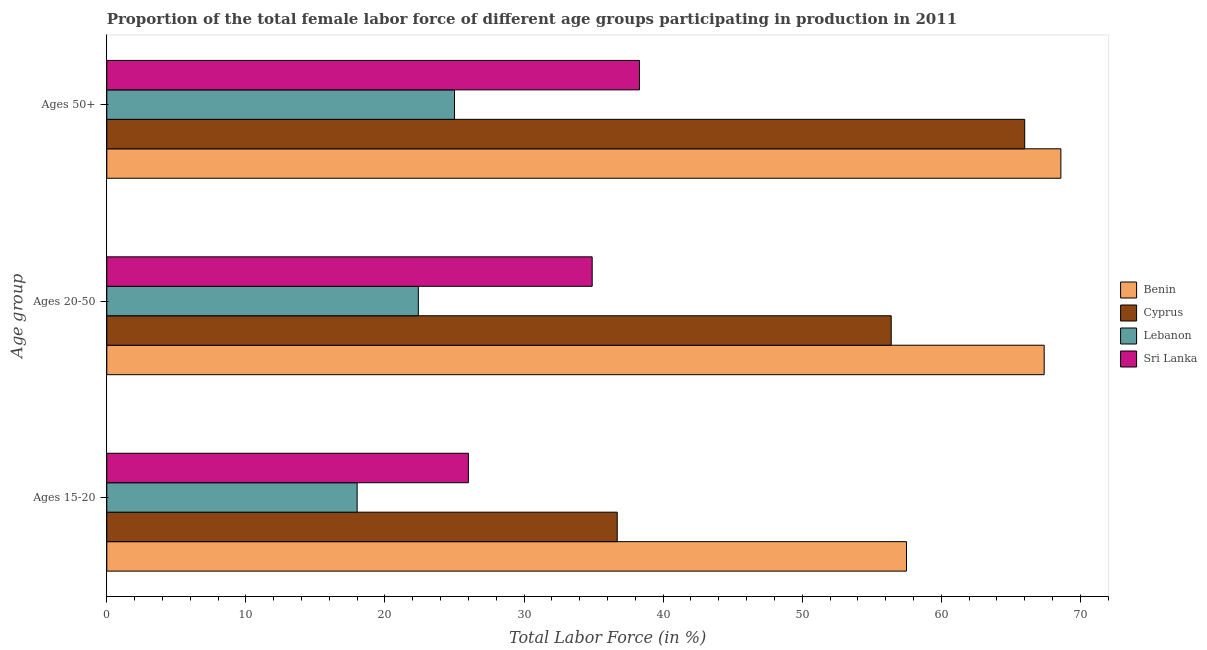Are the number of bars on each tick of the Y-axis equal?
Ensure brevity in your answer.  Yes. How many bars are there on the 1st tick from the bottom?
Your answer should be very brief. 4. What is the label of the 1st group of bars from the top?
Your answer should be compact. Ages 50+. What is the percentage of female labor force within the age group 20-50 in Sri Lanka?
Ensure brevity in your answer.  34.9. Across all countries, what is the maximum percentage of female labor force above age 50?
Your answer should be very brief. 68.6. Across all countries, what is the minimum percentage of female labor force within the age group 20-50?
Provide a succinct answer. 22.4. In which country was the percentage of female labor force within the age group 20-50 maximum?
Offer a terse response. Benin. In which country was the percentage of female labor force above age 50 minimum?
Offer a terse response. Lebanon. What is the total percentage of female labor force within the age group 15-20 in the graph?
Your answer should be very brief. 138.2. What is the difference between the percentage of female labor force above age 50 in Benin and that in Cyprus?
Ensure brevity in your answer.  2.6. What is the difference between the percentage of female labor force within the age group 20-50 in Cyprus and the percentage of female labor force within the age group 15-20 in Benin?
Provide a succinct answer. -1.1. What is the average percentage of female labor force within the age group 20-50 per country?
Offer a terse response. 45.28. What is the difference between the percentage of female labor force within the age group 20-50 and percentage of female labor force above age 50 in Sri Lanka?
Make the answer very short. -3.4. In how many countries, is the percentage of female labor force within the age group 15-20 greater than 42 %?
Ensure brevity in your answer.  1. What is the ratio of the percentage of female labor force above age 50 in Cyprus to that in Sri Lanka?
Give a very brief answer. 1.72. Is the difference between the percentage of female labor force above age 50 in Lebanon and Cyprus greater than the difference between the percentage of female labor force within the age group 15-20 in Lebanon and Cyprus?
Provide a succinct answer. No. What is the difference between the highest and the second highest percentage of female labor force above age 50?
Offer a very short reply. 2.6. What is the difference between the highest and the lowest percentage of female labor force within the age group 20-50?
Your answer should be very brief. 45. In how many countries, is the percentage of female labor force within the age group 15-20 greater than the average percentage of female labor force within the age group 15-20 taken over all countries?
Provide a short and direct response. 2. What does the 3rd bar from the top in Ages 20-50 represents?
Provide a short and direct response. Cyprus. What does the 4th bar from the bottom in Ages 15-20 represents?
Offer a terse response. Sri Lanka. Is it the case that in every country, the sum of the percentage of female labor force within the age group 15-20 and percentage of female labor force within the age group 20-50 is greater than the percentage of female labor force above age 50?
Keep it short and to the point. Yes. What is the difference between two consecutive major ticks on the X-axis?
Provide a succinct answer. 10. Does the graph contain any zero values?
Give a very brief answer. No. What is the title of the graph?
Your response must be concise. Proportion of the total female labor force of different age groups participating in production in 2011. Does "Guyana" appear as one of the legend labels in the graph?
Provide a short and direct response. No. What is the label or title of the X-axis?
Make the answer very short. Total Labor Force (in %). What is the label or title of the Y-axis?
Ensure brevity in your answer.  Age group. What is the Total Labor Force (in %) in Benin in Ages 15-20?
Your answer should be very brief. 57.5. What is the Total Labor Force (in %) in Cyprus in Ages 15-20?
Keep it short and to the point. 36.7. What is the Total Labor Force (in %) in Sri Lanka in Ages 15-20?
Ensure brevity in your answer.  26. What is the Total Labor Force (in %) in Benin in Ages 20-50?
Make the answer very short. 67.4. What is the Total Labor Force (in %) in Cyprus in Ages 20-50?
Offer a terse response. 56.4. What is the Total Labor Force (in %) of Lebanon in Ages 20-50?
Your answer should be very brief. 22.4. What is the Total Labor Force (in %) in Sri Lanka in Ages 20-50?
Offer a very short reply. 34.9. What is the Total Labor Force (in %) of Benin in Ages 50+?
Give a very brief answer. 68.6. What is the Total Labor Force (in %) of Cyprus in Ages 50+?
Give a very brief answer. 66. What is the Total Labor Force (in %) in Sri Lanka in Ages 50+?
Ensure brevity in your answer.  38.3. Across all Age group, what is the maximum Total Labor Force (in %) in Benin?
Ensure brevity in your answer.  68.6. Across all Age group, what is the maximum Total Labor Force (in %) of Cyprus?
Your answer should be compact. 66. Across all Age group, what is the maximum Total Labor Force (in %) of Sri Lanka?
Your answer should be very brief. 38.3. Across all Age group, what is the minimum Total Labor Force (in %) of Benin?
Make the answer very short. 57.5. Across all Age group, what is the minimum Total Labor Force (in %) of Cyprus?
Your response must be concise. 36.7. Across all Age group, what is the minimum Total Labor Force (in %) in Lebanon?
Give a very brief answer. 18. Across all Age group, what is the minimum Total Labor Force (in %) of Sri Lanka?
Your response must be concise. 26. What is the total Total Labor Force (in %) of Benin in the graph?
Your response must be concise. 193.5. What is the total Total Labor Force (in %) of Cyprus in the graph?
Ensure brevity in your answer.  159.1. What is the total Total Labor Force (in %) in Lebanon in the graph?
Provide a short and direct response. 65.4. What is the total Total Labor Force (in %) of Sri Lanka in the graph?
Ensure brevity in your answer.  99.2. What is the difference between the Total Labor Force (in %) of Cyprus in Ages 15-20 and that in Ages 20-50?
Keep it short and to the point. -19.7. What is the difference between the Total Labor Force (in %) of Cyprus in Ages 15-20 and that in Ages 50+?
Ensure brevity in your answer.  -29.3. What is the difference between the Total Labor Force (in %) of Lebanon in Ages 15-20 and that in Ages 50+?
Offer a very short reply. -7. What is the difference between the Total Labor Force (in %) of Sri Lanka in Ages 15-20 and that in Ages 50+?
Keep it short and to the point. -12.3. What is the difference between the Total Labor Force (in %) in Benin in Ages 20-50 and that in Ages 50+?
Your response must be concise. -1.2. What is the difference between the Total Labor Force (in %) of Cyprus in Ages 20-50 and that in Ages 50+?
Your answer should be compact. -9.6. What is the difference between the Total Labor Force (in %) in Lebanon in Ages 20-50 and that in Ages 50+?
Offer a very short reply. -2.6. What is the difference between the Total Labor Force (in %) of Benin in Ages 15-20 and the Total Labor Force (in %) of Cyprus in Ages 20-50?
Ensure brevity in your answer.  1.1. What is the difference between the Total Labor Force (in %) of Benin in Ages 15-20 and the Total Labor Force (in %) of Lebanon in Ages 20-50?
Offer a terse response. 35.1. What is the difference between the Total Labor Force (in %) in Benin in Ages 15-20 and the Total Labor Force (in %) in Sri Lanka in Ages 20-50?
Offer a terse response. 22.6. What is the difference between the Total Labor Force (in %) in Cyprus in Ages 15-20 and the Total Labor Force (in %) in Lebanon in Ages 20-50?
Provide a succinct answer. 14.3. What is the difference between the Total Labor Force (in %) of Lebanon in Ages 15-20 and the Total Labor Force (in %) of Sri Lanka in Ages 20-50?
Offer a very short reply. -16.9. What is the difference between the Total Labor Force (in %) of Benin in Ages 15-20 and the Total Labor Force (in %) of Cyprus in Ages 50+?
Your response must be concise. -8.5. What is the difference between the Total Labor Force (in %) of Benin in Ages 15-20 and the Total Labor Force (in %) of Lebanon in Ages 50+?
Provide a succinct answer. 32.5. What is the difference between the Total Labor Force (in %) of Cyprus in Ages 15-20 and the Total Labor Force (in %) of Lebanon in Ages 50+?
Your answer should be very brief. 11.7. What is the difference between the Total Labor Force (in %) of Cyprus in Ages 15-20 and the Total Labor Force (in %) of Sri Lanka in Ages 50+?
Provide a succinct answer. -1.6. What is the difference between the Total Labor Force (in %) of Lebanon in Ages 15-20 and the Total Labor Force (in %) of Sri Lanka in Ages 50+?
Offer a terse response. -20.3. What is the difference between the Total Labor Force (in %) in Benin in Ages 20-50 and the Total Labor Force (in %) in Cyprus in Ages 50+?
Give a very brief answer. 1.4. What is the difference between the Total Labor Force (in %) in Benin in Ages 20-50 and the Total Labor Force (in %) in Lebanon in Ages 50+?
Ensure brevity in your answer.  42.4. What is the difference between the Total Labor Force (in %) of Benin in Ages 20-50 and the Total Labor Force (in %) of Sri Lanka in Ages 50+?
Your answer should be compact. 29.1. What is the difference between the Total Labor Force (in %) of Cyprus in Ages 20-50 and the Total Labor Force (in %) of Lebanon in Ages 50+?
Your answer should be very brief. 31.4. What is the difference between the Total Labor Force (in %) of Lebanon in Ages 20-50 and the Total Labor Force (in %) of Sri Lanka in Ages 50+?
Make the answer very short. -15.9. What is the average Total Labor Force (in %) of Benin per Age group?
Give a very brief answer. 64.5. What is the average Total Labor Force (in %) in Cyprus per Age group?
Ensure brevity in your answer.  53.03. What is the average Total Labor Force (in %) of Lebanon per Age group?
Offer a very short reply. 21.8. What is the average Total Labor Force (in %) in Sri Lanka per Age group?
Your answer should be compact. 33.07. What is the difference between the Total Labor Force (in %) in Benin and Total Labor Force (in %) in Cyprus in Ages 15-20?
Offer a very short reply. 20.8. What is the difference between the Total Labor Force (in %) in Benin and Total Labor Force (in %) in Lebanon in Ages 15-20?
Ensure brevity in your answer.  39.5. What is the difference between the Total Labor Force (in %) in Benin and Total Labor Force (in %) in Sri Lanka in Ages 15-20?
Ensure brevity in your answer.  31.5. What is the difference between the Total Labor Force (in %) in Cyprus and Total Labor Force (in %) in Sri Lanka in Ages 15-20?
Make the answer very short. 10.7. What is the difference between the Total Labor Force (in %) of Lebanon and Total Labor Force (in %) of Sri Lanka in Ages 15-20?
Offer a terse response. -8. What is the difference between the Total Labor Force (in %) in Benin and Total Labor Force (in %) in Cyprus in Ages 20-50?
Your answer should be compact. 11. What is the difference between the Total Labor Force (in %) in Benin and Total Labor Force (in %) in Lebanon in Ages 20-50?
Offer a terse response. 45. What is the difference between the Total Labor Force (in %) of Benin and Total Labor Force (in %) of Sri Lanka in Ages 20-50?
Make the answer very short. 32.5. What is the difference between the Total Labor Force (in %) in Benin and Total Labor Force (in %) in Cyprus in Ages 50+?
Your answer should be very brief. 2.6. What is the difference between the Total Labor Force (in %) of Benin and Total Labor Force (in %) of Lebanon in Ages 50+?
Your answer should be compact. 43.6. What is the difference between the Total Labor Force (in %) of Benin and Total Labor Force (in %) of Sri Lanka in Ages 50+?
Keep it short and to the point. 30.3. What is the difference between the Total Labor Force (in %) in Cyprus and Total Labor Force (in %) in Lebanon in Ages 50+?
Keep it short and to the point. 41. What is the difference between the Total Labor Force (in %) in Cyprus and Total Labor Force (in %) in Sri Lanka in Ages 50+?
Give a very brief answer. 27.7. What is the difference between the Total Labor Force (in %) of Lebanon and Total Labor Force (in %) of Sri Lanka in Ages 50+?
Your answer should be very brief. -13.3. What is the ratio of the Total Labor Force (in %) in Benin in Ages 15-20 to that in Ages 20-50?
Your response must be concise. 0.85. What is the ratio of the Total Labor Force (in %) in Cyprus in Ages 15-20 to that in Ages 20-50?
Your answer should be very brief. 0.65. What is the ratio of the Total Labor Force (in %) of Lebanon in Ages 15-20 to that in Ages 20-50?
Give a very brief answer. 0.8. What is the ratio of the Total Labor Force (in %) in Sri Lanka in Ages 15-20 to that in Ages 20-50?
Ensure brevity in your answer.  0.74. What is the ratio of the Total Labor Force (in %) in Benin in Ages 15-20 to that in Ages 50+?
Provide a succinct answer. 0.84. What is the ratio of the Total Labor Force (in %) of Cyprus in Ages 15-20 to that in Ages 50+?
Give a very brief answer. 0.56. What is the ratio of the Total Labor Force (in %) in Lebanon in Ages 15-20 to that in Ages 50+?
Make the answer very short. 0.72. What is the ratio of the Total Labor Force (in %) of Sri Lanka in Ages 15-20 to that in Ages 50+?
Give a very brief answer. 0.68. What is the ratio of the Total Labor Force (in %) in Benin in Ages 20-50 to that in Ages 50+?
Give a very brief answer. 0.98. What is the ratio of the Total Labor Force (in %) in Cyprus in Ages 20-50 to that in Ages 50+?
Provide a short and direct response. 0.85. What is the ratio of the Total Labor Force (in %) in Lebanon in Ages 20-50 to that in Ages 50+?
Provide a short and direct response. 0.9. What is the ratio of the Total Labor Force (in %) in Sri Lanka in Ages 20-50 to that in Ages 50+?
Offer a very short reply. 0.91. What is the difference between the highest and the second highest Total Labor Force (in %) in Benin?
Your response must be concise. 1.2. What is the difference between the highest and the second highest Total Labor Force (in %) in Cyprus?
Your answer should be compact. 9.6. What is the difference between the highest and the second highest Total Labor Force (in %) in Lebanon?
Give a very brief answer. 2.6. What is the difference between the highest and the lowest Total Labor Force (in %) in Cyprus?
Make the answer very short. 29.3. What is the difference between the highest and the lowest Total Labor Force (in %) of Lebanon?
Keep it short and to the point. 7. What is the difference between the highest and the lowest Total Labor Force (in %) in Sri Lanka?
Your response must be concise. 12.3. 